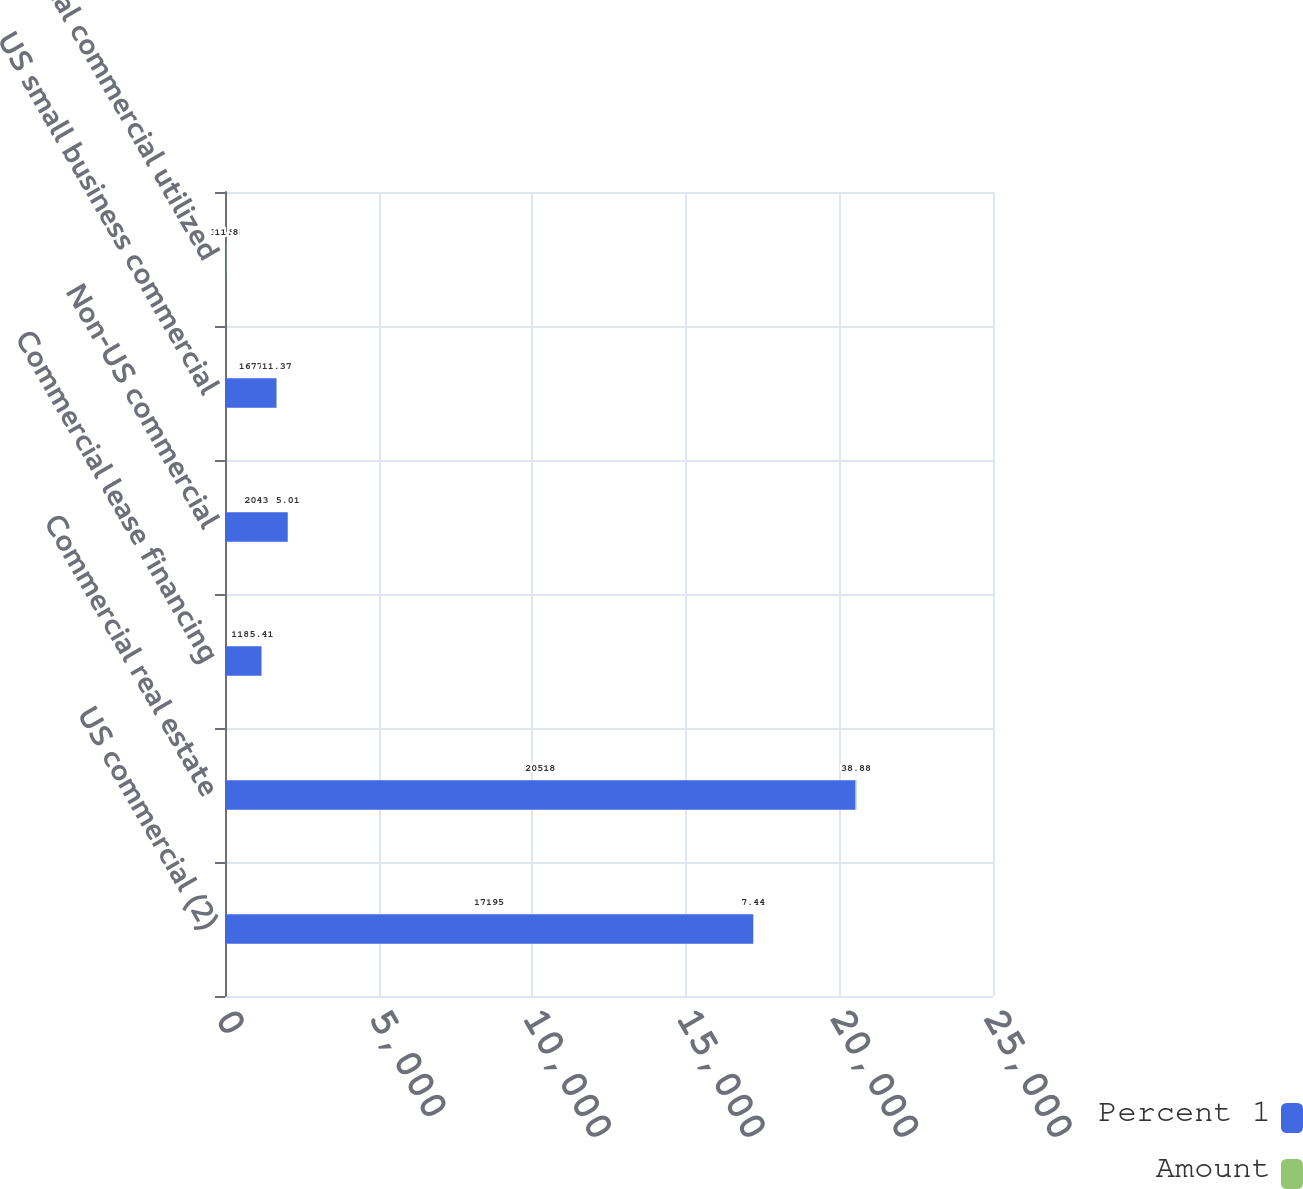<chart> <loc_0><loc_0><loc_500><loc_500><stacked_bar_chart><ecel><fcel>US commercial (2)<fcel>Commercial real estate<fcel>Commercial lease financing<fcel>Non-US commercial<fcel>US small business commercial<fcel>Total commercial utilized<nl><fcel>Percent 1<fcel>17195<fcel>20518<fcel>1188<fcel>2043<fcel>1677<fcel>38.88<nl><fcel>Amount<fcel>7.44<fcel>38.88<fcel>5.41<fcel>5.01<fcel>11.37<fcel>11.8<nl></chart> 